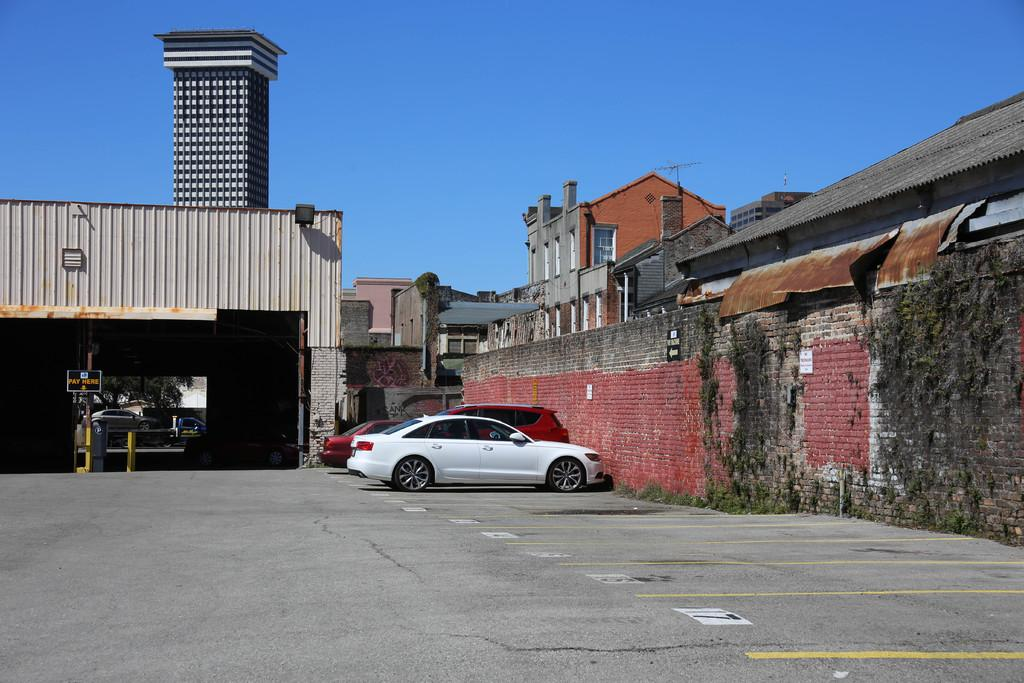How many vehicles are parked beside the brick wall in the image? There are three vehicles parked beside the brick wall in the image. What type of structures can be seen around the wall? There are houses and buildings around the wall. What is visible in the background of the image? The background of the image includes a blue sky. What type of shop can be seen in the image? There is no shop present in the image; it features vehicles parked beside a brick wall with houses and buildings in the background. What type of wire is used to connect the vehicles in the image? There is no wire connecting the vehicles in the image; they are parked beside the brick wall. 